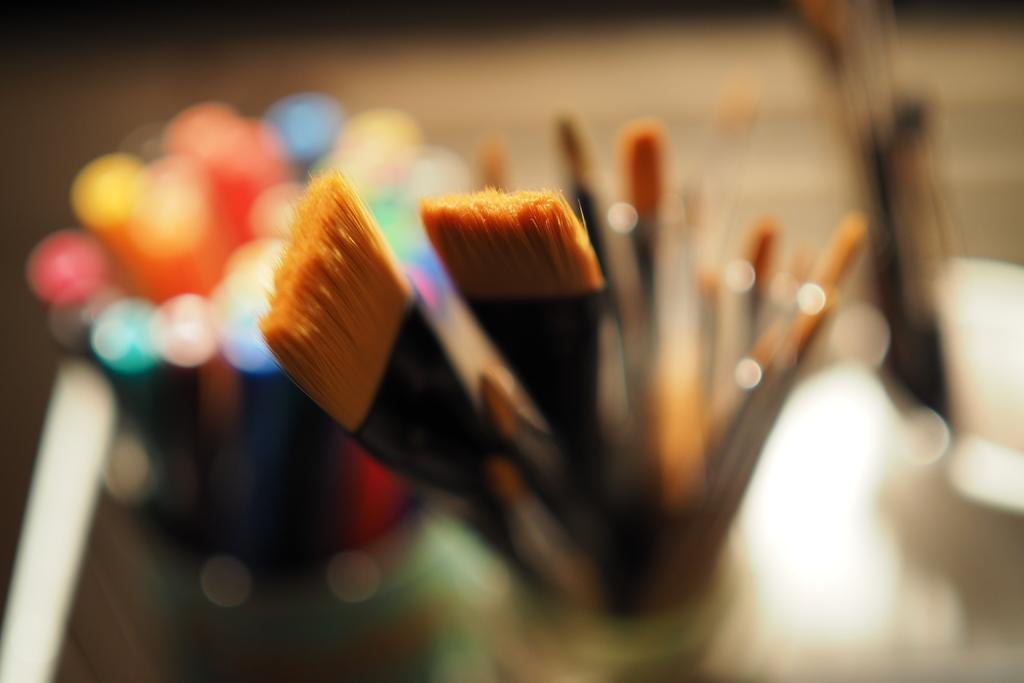How would you summarize this image in a sentence or two? In this picture there are paint brushes in the center of the image and there are colors on the left side of the image. 